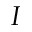Convert formula to latex. <formula><loc_0><loc_0><loc_500><loc_500>I</formula> 